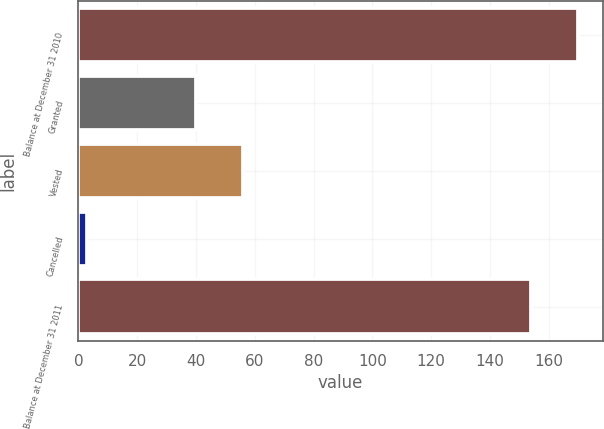Convert chart to OTSL. <chart><loc_0><loc_0><loc_500><loc_500><bar_chart><fcel>Balance at December 31 2010<fcel>Granted<fcel>Vested<fcel>Cancelled<fcel>Balance at December 31 2011<nl><fcel>169.9<fcel>40<fcel>55.9<fcel>3<fcel>154<nl></chart> 